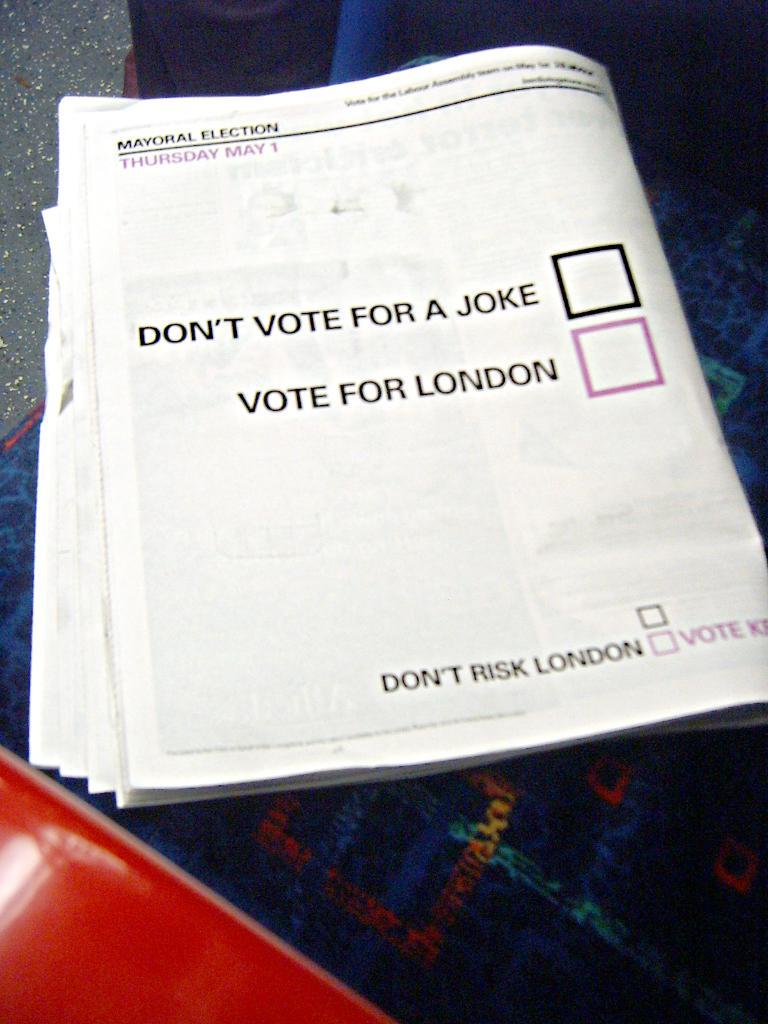What is the ad telling you to not risk?
Provide a succinct answer. London. 